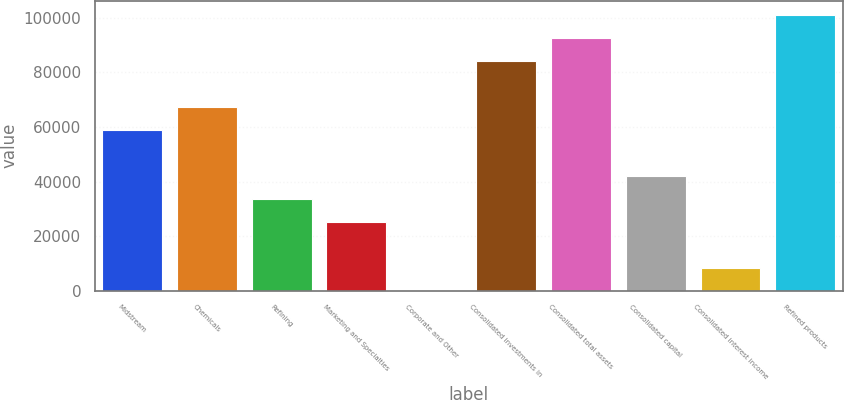Convert chart to OTSL. <chart><loc_0><loc_0><loc_500><loc_500><bar_chart><fcel>Midstream<fcel>Chemicals<fcel>Refining<fcel>Marketing and Specialties<fcel>Corporate and Other<fcel>Consolidated investments in<fcel>Consolidated total assets<fcel>Consolidated capital<fcel>Consolidated interest income<fcel>Refined products<nl><fcel>58995.6<fcel>67423.4<fcel>33712.2<fcel>25284.4<fcel>1<fcel>84279<fcel>92706.8<fcel>42140<fcel>8428.8<fcel>101135<nl></chart> 